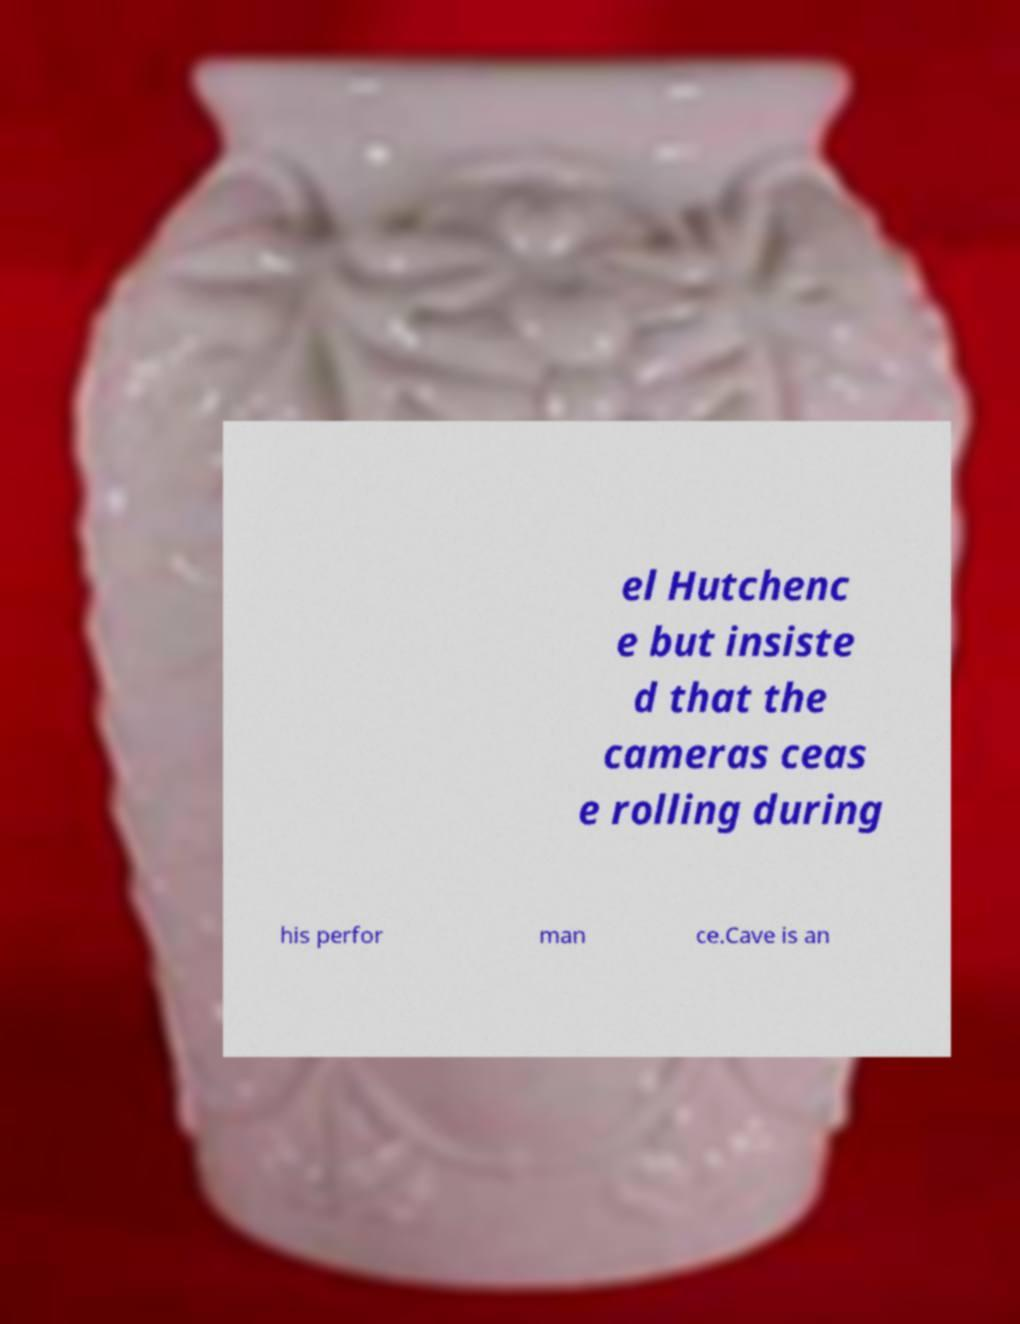I need the written content from this picture converted into text. Can you do that? el Hutchenc e but insiste d that the cameras ceas e rolling during his perfor man ce.Cave is an 